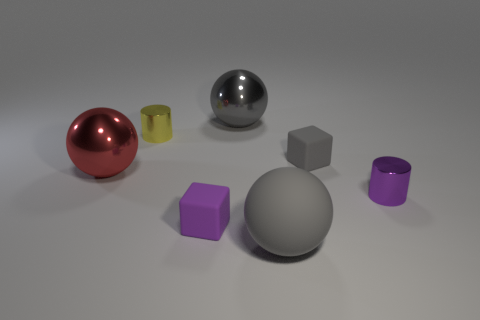Subtract all cyan balls. Subtract all gray cubes. How many balls are left? 3 Add 2 gray matte objects. How many objects exist? 9 Subtract all cylinders. How many objects are left? 5 Add 7 rubber balls. How many rubber balls are left? 8 Add 3 small metallic objects. How many small metallic objects exist? 5 Subtract 0 yellow cubes. How many objects are left? 7 Subtract all large gray matte things. Subtract all large brown blocks. How many objects are left? 6 